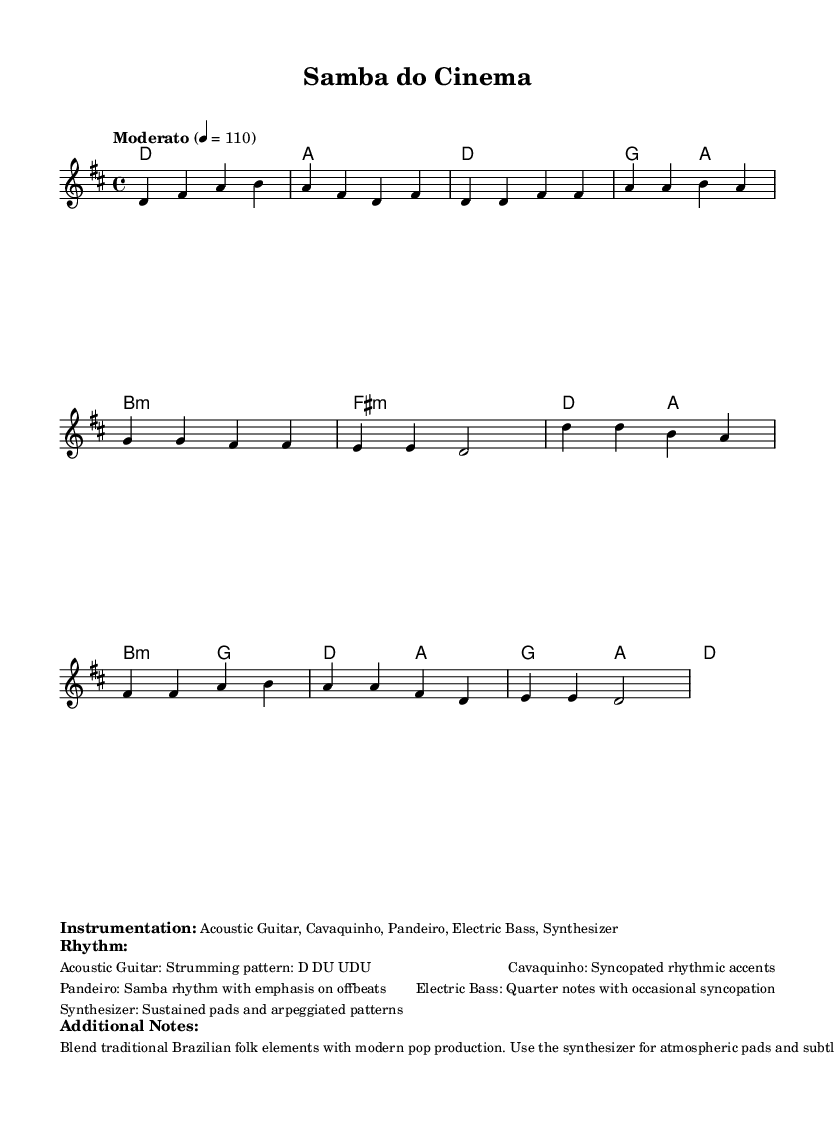What is the key signature of this music? The key signature is D major, which consists of two sharps (F# and C#). It can be identified by looking at the key signature section at the beginning of the staff.
Answer: D major What is the time signature of this music? The time signature is 4/4, which means there are four beats in each measure and each quarter note gets one beat. This is indicated at the beginning of the score with the time signature notation.
Answer: 4/4 What is the tempo marking written in the music? The tempo marking is "Moderato" with a metronome marking of quarter note equals 110 beats per minute. This can be found at the beginning of the score where the tempo is specified.
Answer: Moderato Which traditional Brazilian instrument is prominently featured in the instrumentation? The pandeiro is one of the traditional instruments listed in the instrumentation. The instrumentation is outlined in the markup section, indicating the blend of traditional and modern elements.
Answer: Pandeiro How many measures are in the verse section of the song? The verse section consists of four measures, which can be counted by identifying the verse notation and counting each measure within that section of the music.
Answer: 4 measures What type of rhythm is represented by the pandeiro? The rhythm represented by the pandeiro is a samba rhythm with an emphasis on offbeats. This is specified in the rhythm section of the markup, highlighting traditional rhythmic characteristics of Brazilian music.
Answer: Samba rhythm What is the function of the synthesizer in this composition? The synthesizer provides atmospheric pads and subtle electronic textures. This function is indicated in the additional notes section of the markup, describing the role of each instrument in the fusion style.
Answer: Atmospheric pads 